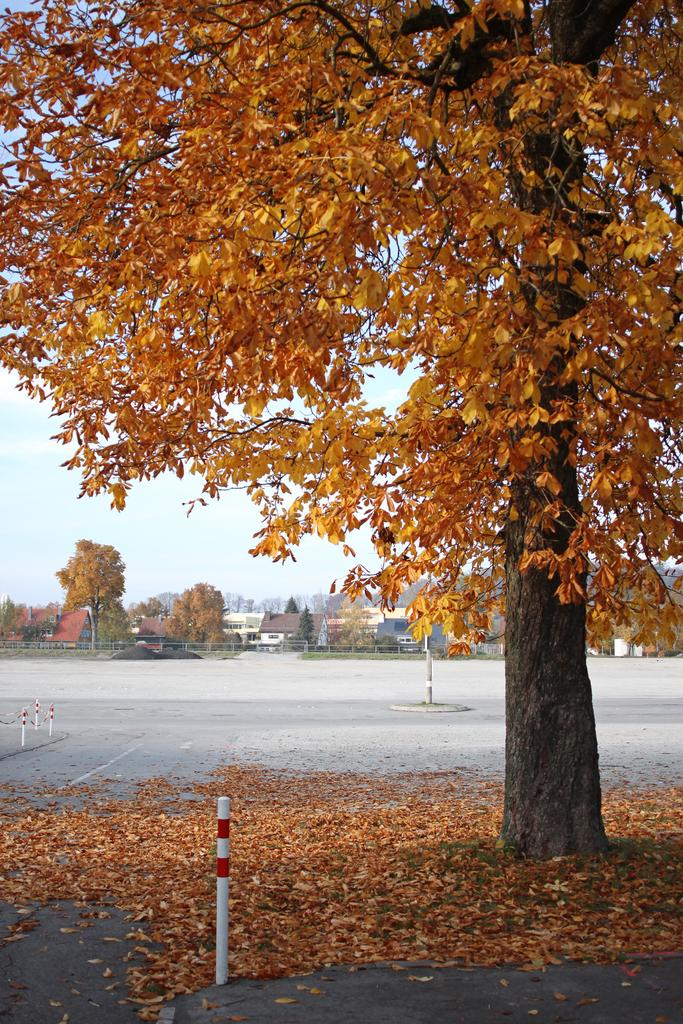What is blocking the road in the image? There is a tree on the road in the image. What can be seen in the distance behind the tree? There are buildings and trees in the background of the image. What else is present in the background of the image? There are sticks and the sky visible in the background of the image. How many babies are playing with the girl in the image? There are no babies or girls present in the image; it only features a tree on the road and various elements in the background. 